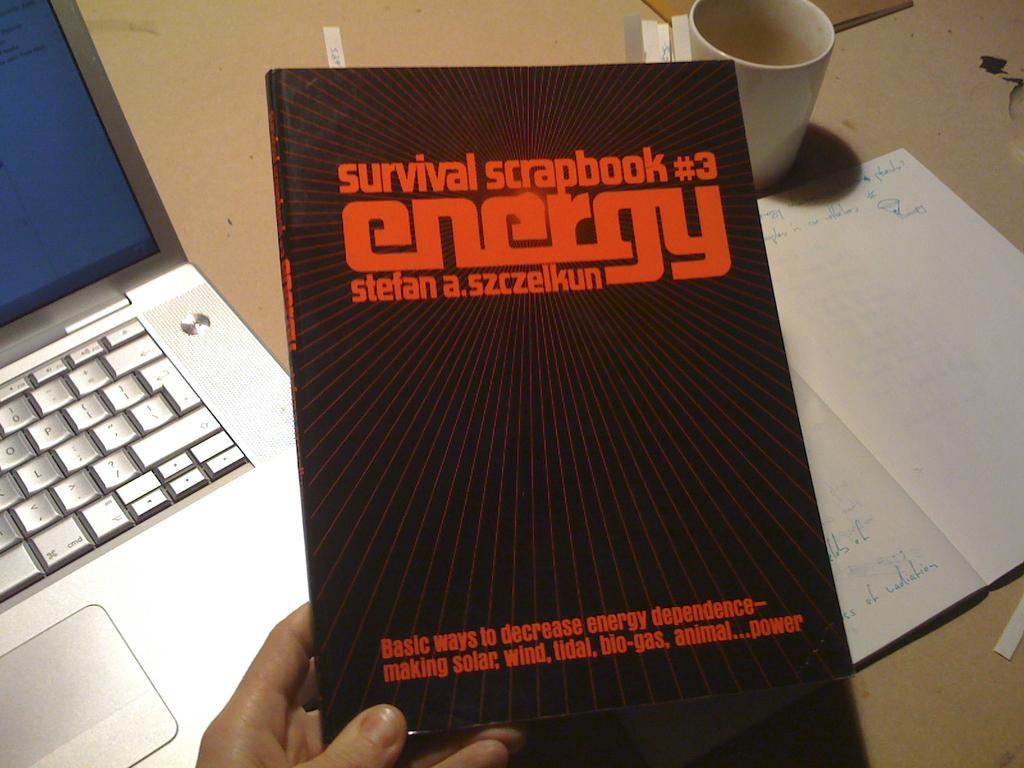<image>
Offer a succinct explanation of the picture presented. hand holding survival scrapbook #3 energy book with a laptop sitting on table below 